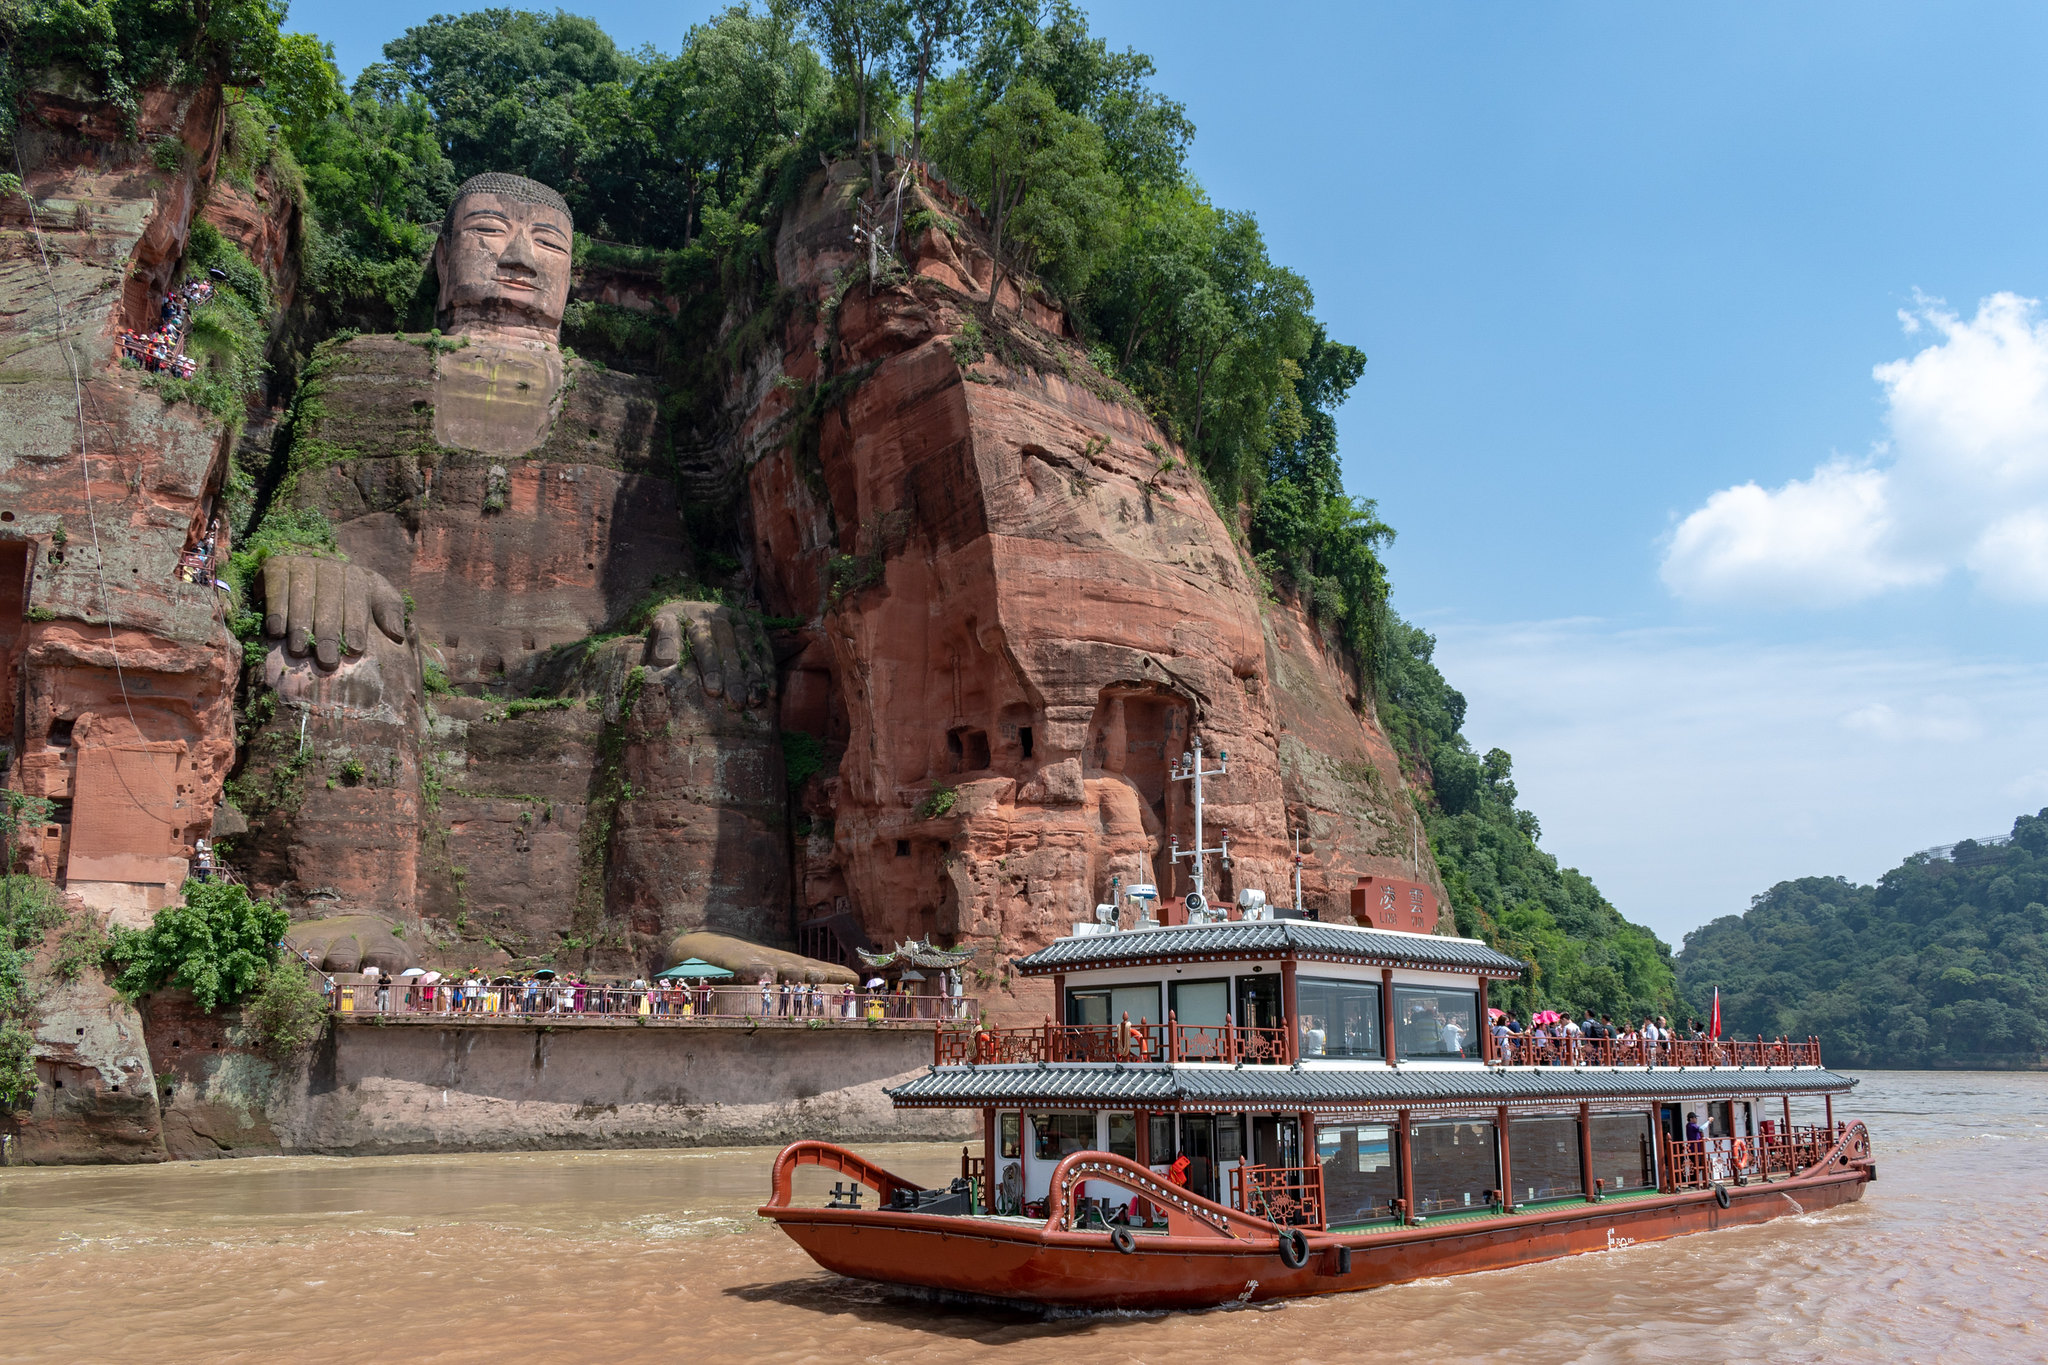How does this location integrate with the natural environment? The Leshan Giant Buddha is masterfully integrated into the natural environment of the cliffs overlooking the river. This harmony between the man-made and natural world is immediately evident in the way the statue appears to seamlessly emerge from the rock face. The lush greenery climbing up the cliffs adds a vibrant, natural framing to the statue, enhancing its serene and timeless presence. The river below reflects the surrounding beauty, offering a dynamic interaction between the steady stone Buddha and the ever-moving water. This integration makes the site not only a marvel of human engineering but also a picturesque blend of artistry and natural splendor. 